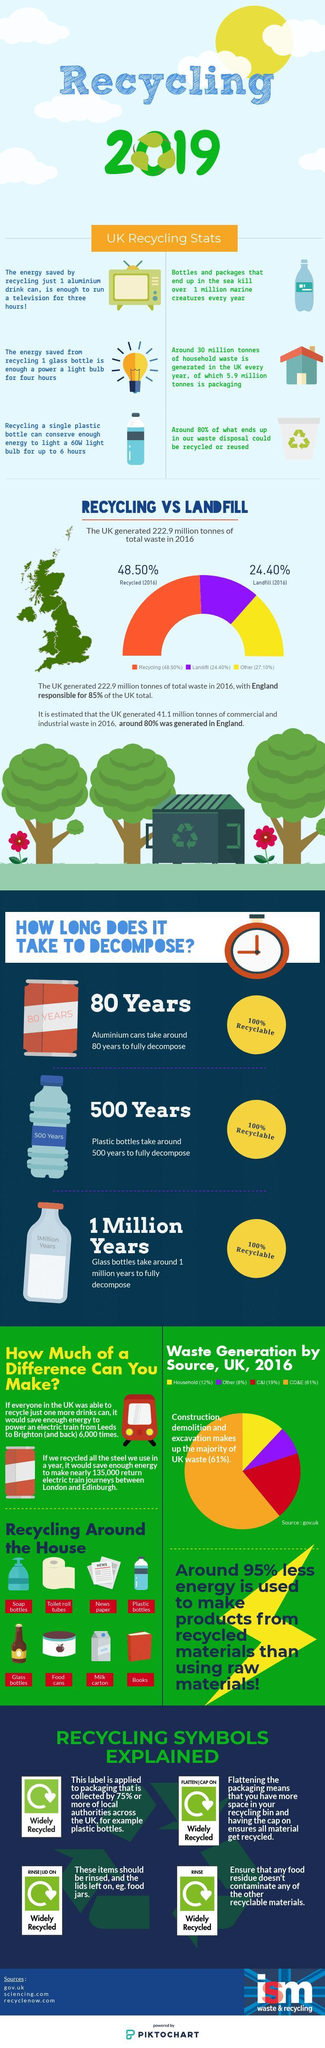Which among the three takes the longest time to decompose, Glass bottles, Aluminium cans, or Plastic bottles?
Answer the question with a short phrase. Glass bottles Which color denotes the largest source of waste generation in the UK, yellow, orange, or red? orange How many waste generation sources are give in the graph? 4 Which source has the lowest percentage of waste generation in UK? Other What does the yellow color in the graph denote, Recycled, Landfill, or Others? Others How many recycling symbols are explained in the infographic? 4 